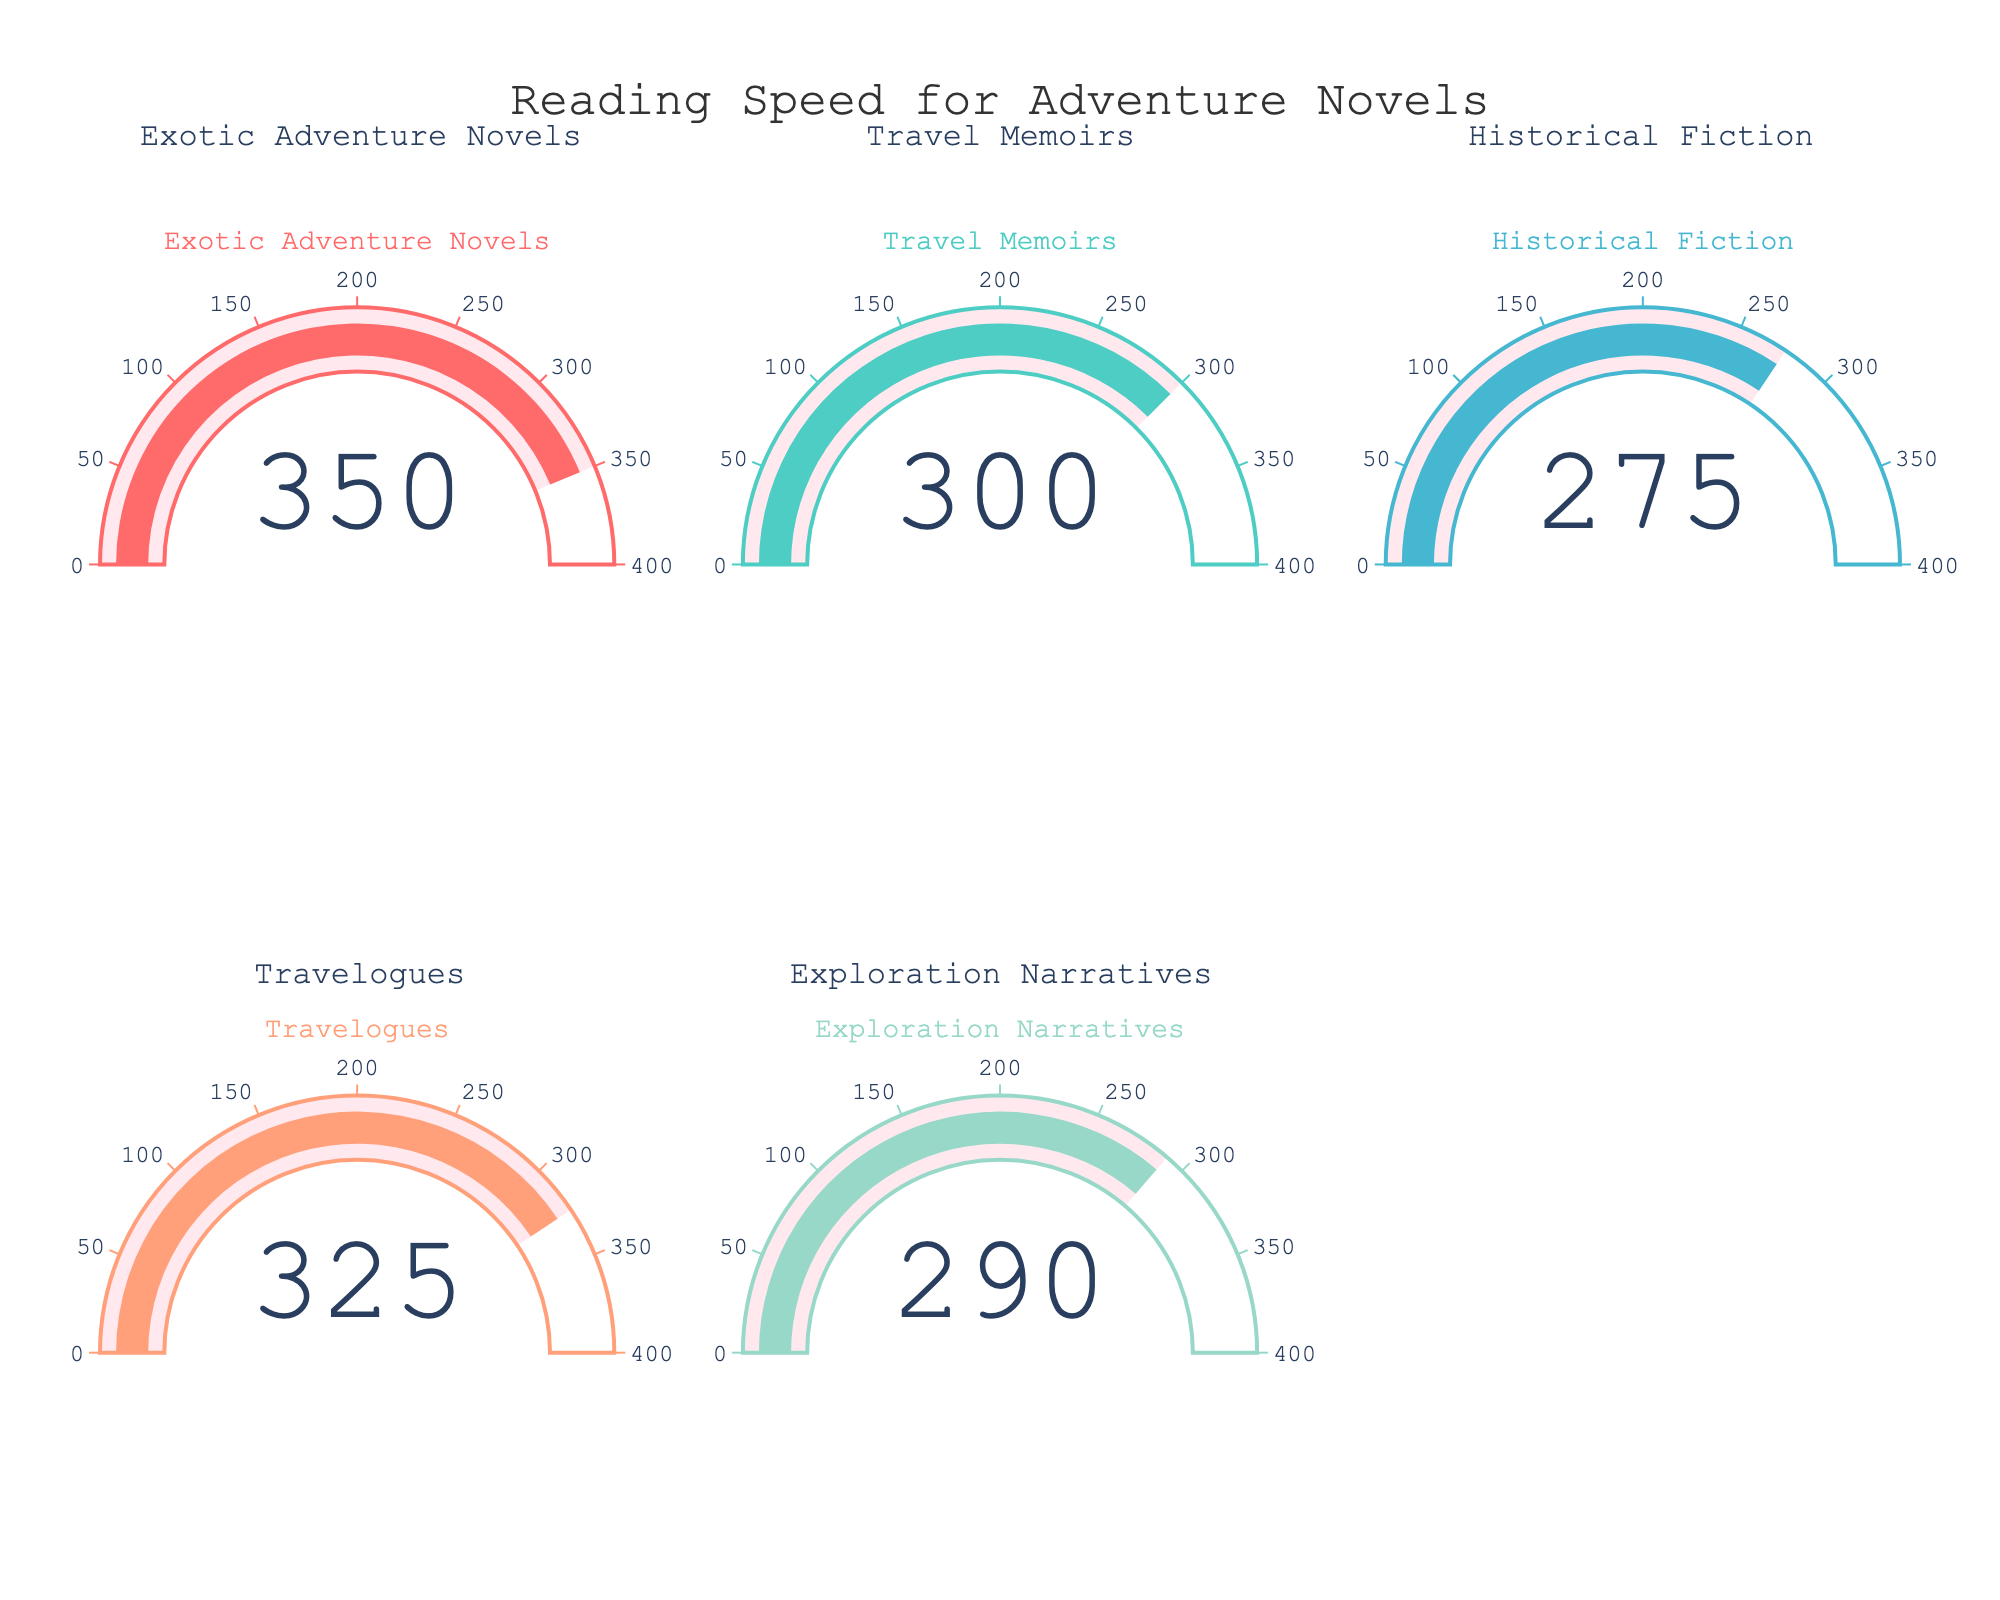What's the value for reading speed in Exotic Adventure Novels? The gauge chart displays a value under the heading "Exotic Adventure Novels". This value is 350 words per minute.
Answer: 350 How does the reading speed for Travel Memoirs compare to Travelogues? The Travel Memoirs gauge displays a value of 300 words per minute, while the Travelogues gauge shows 325 words per minute. 325 - 300 = 25, so reading Travelogues is 25 words per minute faster.
Answer: 25 words per minute faster What reading type has the lowest reading speed? Among the given gauges, Historical Fiction shows the lowest value, which stands at 275 words per minute.
Answer: Historical Fiction Calculate the average reading speed across all the provided reading types. Summing the values: 350 (Exotic Adventure Novels) + 300 (Travel Memoirs) + 275 (Historical Fiction) + 325 (Travelogues) + 290 (Exploration Narratives) = 1540. Dividing by the number of types (5) gives an average: 1540 / 5 = 308 words per minute.
Answer: 308 words per minute Which reading type is closest in speed to Exploration Narratives? Exploration Narratives has a value of 290 words per minute. Comparing this with other types: Exotic Adventure Novels (350), Travel Memoirs (300), Historical Fiction (275), Travelogues (325), the closest is Travel Memoirs at 300 words per minute.
Answer: Travel Memoirs What is the difference between the fastest and slowest reading speeds? The fastest reading speed is Exotic Adventure Novels at 350 words per minute, and the slowest is Historical Fiction at 275 words per minute. The difference is 350 - 275 = 75 words per minute.
Answer: 75 words per minute What's the median reading speed among the given reading types? To find the median, list the speeds in ascending order: 275, 290, 300, 325, 350. The median is the middle value, which is 300 words per minute.
Answer: 300 words per minute How many reading types have speeds above 300 words per minute? Among the reading types, Exotic Adventure Novels (350), Travelogues (325) exceed 300 words per minute. Exploration Narratives (290), Historical Fiction (275), and Travel Memoirs (300) do not exceed 300 words per minute. Therefore, two types are above 300.
Answer: 2 Is the reading speed for Historical Fiction less than for Exploration Narratives? The gauge value for Historical Fiction is 275 words per minute, while for Exploration Narratives, it is 290 words per minute, so Historical Fiction is less.
Answer: Yes 